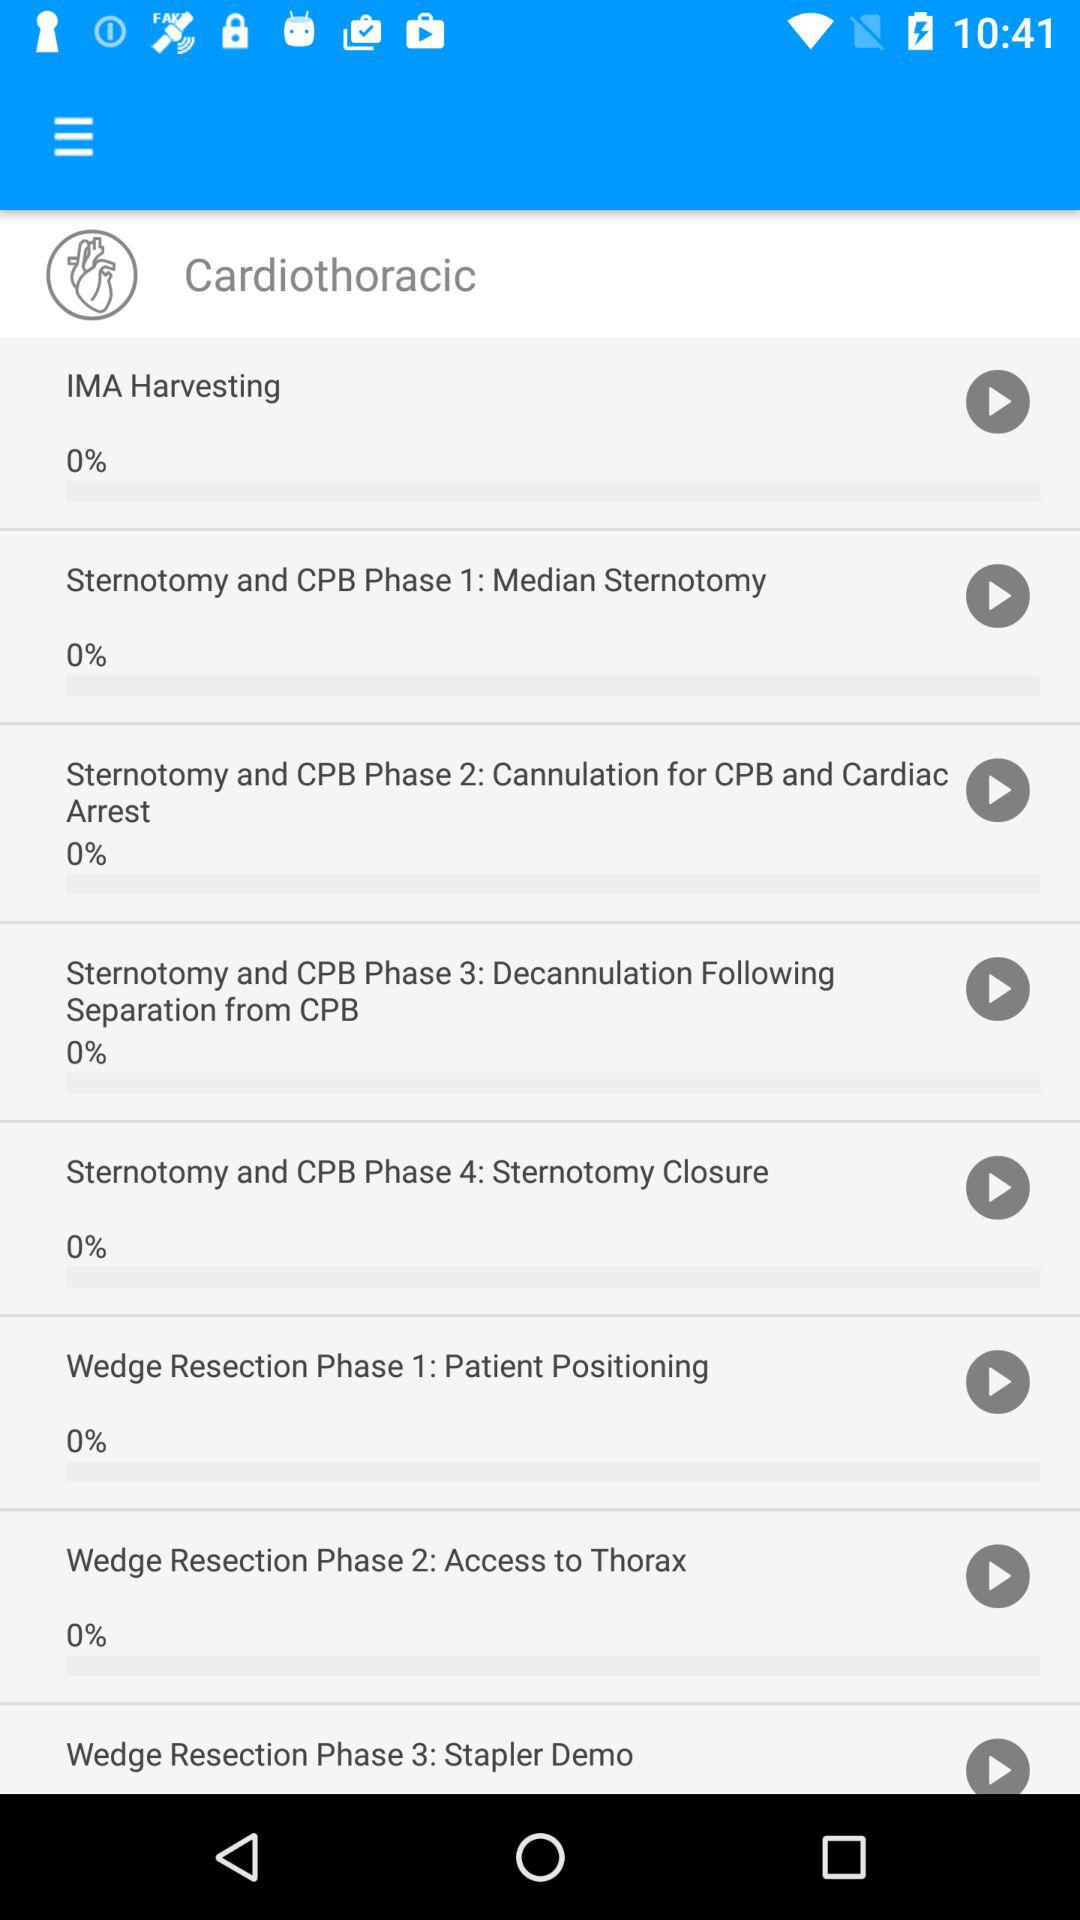What's the percentage of "IMA harvesting"? The percentage is 0. 